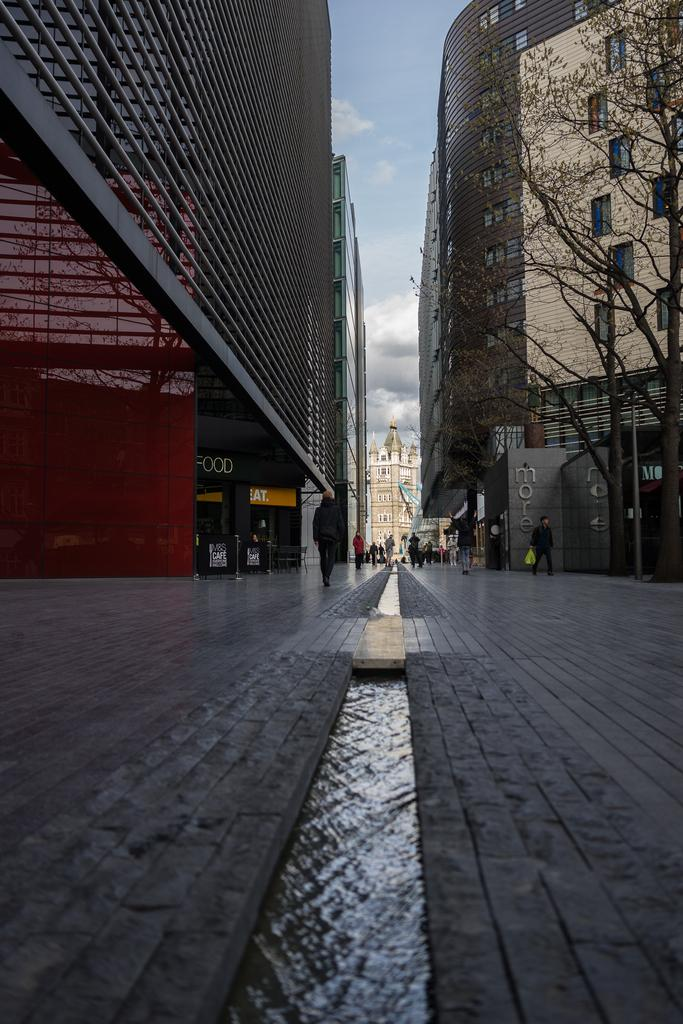<image>
Share a concise interpretation of the image provided. an area outside with a small river running in front of a door with a 'food' sign above it 